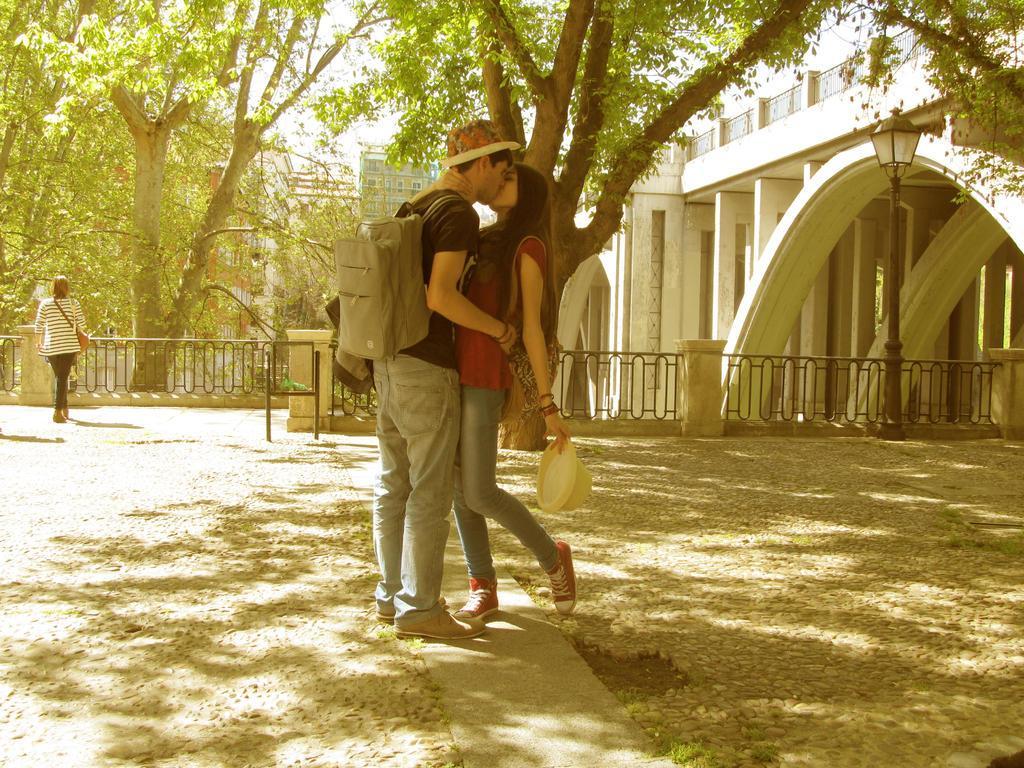Could you give a brief overview of what you see in this image? In this picture we see 2 people with hats standing on the road and kissing each other. In the background, we can see trees, buildings, lamp post, iron railings and a person on the road. 